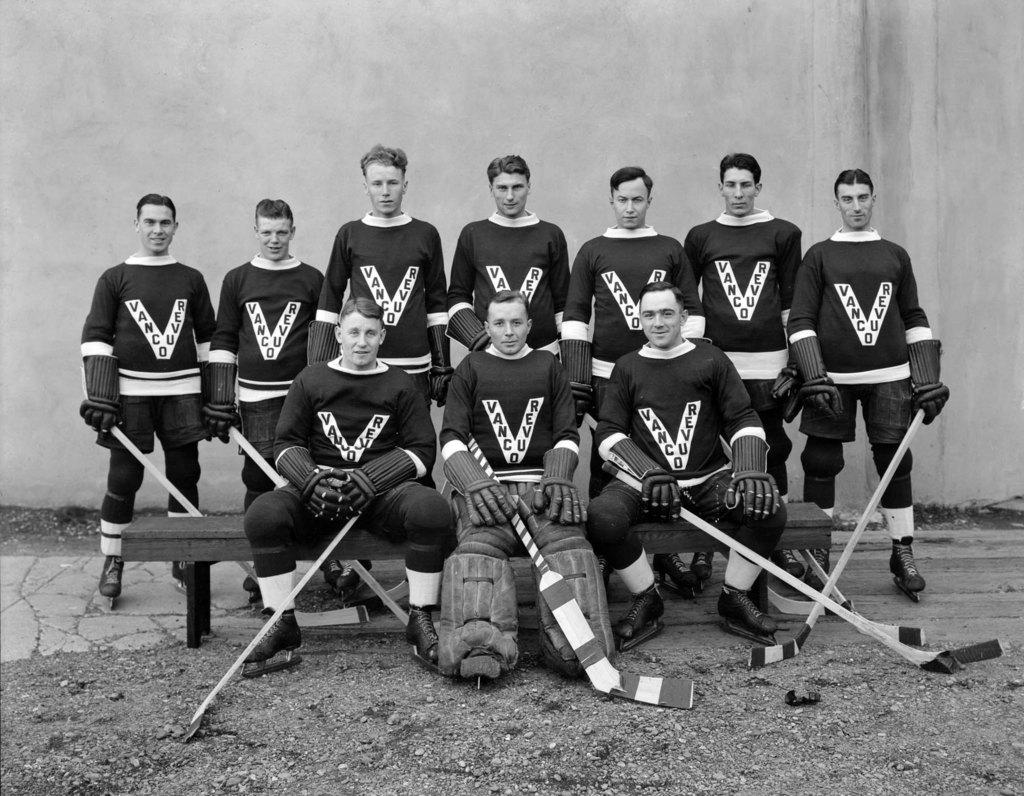Provide a one-sentence caption for the provided image. The Vancouver hockey goalie sits in the middle of his team mates, on the bench. 